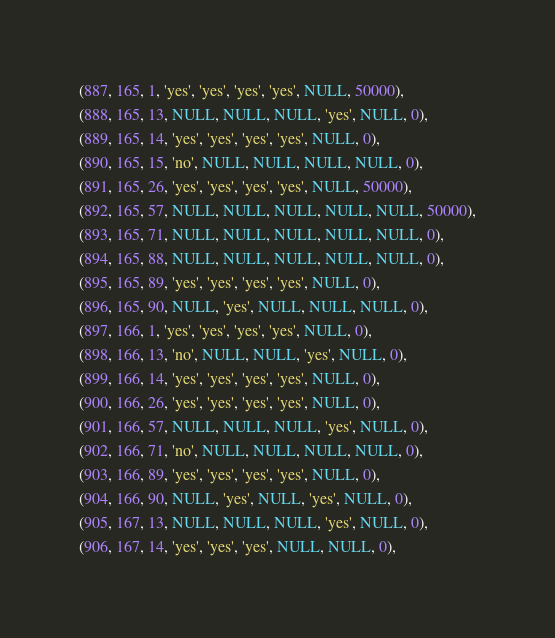<code> <loc_0><loc_0><loc_500><loc_500><_SQL_>(887, 165, 1, 'yes', 'yes', 'yes', 'yes', NULL, 50000),
(888, 165, 13, NULL, NULL, NULL, 'yes', NULL, 0),
(889, 165, 14, 'yes', 'yes', 'yes', 'yes', NULL, 0),
(890, 165, 15, 'no', NULL, NULL, NULL, NULL, 0),
(891, 165, 26, 'yes', 'yes', 'yes', 'yes', NULL, 50000),
(892, 165, 57, NULL, NULL, NULL, NULL, NULL, 50000),
(893, 165, 71, NULL, NULL, NULL, NULL, NULL, 0),
(894, 165, 88, NULL, NULL, NULL, NULL, NULL, 0),
(895, 165, 89, 'yes', 'yes', 'yes', 'yes', NULL, 0),
(896, 165, 90, NULL, 'yes', NULL, NULL, NULL, 0),
(897, 166, 1, 'yes', 'yes', 'yes', 'yes', NULL, 0),
(898, 166, 13, 'no', NULL, NULL, 'yes', NULL, 0),
(899, 166, 14, 'yes', 'yes', 'yes', 'yes', NULL, 0),
(900, 166, 26, 'yes', 'yes', 'yes', 'yes', NULL, 0),
(901, 166, 57, NULL, NULL, NULL, 'yes', NULL, 0),
(902, 166, 71, 'no', NULL, NULL, NULL, NULL, 0),
(903, 166, 89, 'yes', 'yes', 'yes', 'yes', NULL, 0),
(904, 166, 90, NULL, 'yes', NULL, 'yes', NULL, 0),
(905, 167, 13, NULL, NULL, NULL, 'yes', NULL, 0),
(906, 167, 14, 'yes', 'yes', 'yes', NULL, NULL, 0),</code> 